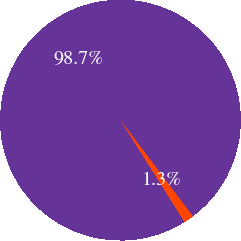Convert chart to OTSL. <chart><loc_0><loc_0><loc_500><loc_500><pie_chart><fcel>Valuation Assumptions<fcel>Expected volatility<nl><fcel>98.67%<fcel>1.33%<nl></chart> 